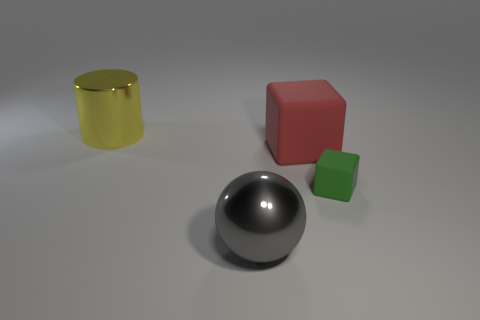Add 2 cylinders. How many objects exist? 6 Subtract 1 cubes. How many cubes are left? 1 Subtract all cyan cylinders. Subtract all brown cubes. How many cylinders are left? 1 Subtract all yellow balls. How many red blocks are left? 1 Subtract all large yellow cylinders. Subtract all small green cylinders. How many objects are left? 3 Add 4 small green objects. How many small green objects are left? 5 Add 1 big cylinders. How many big cylinders exist? 2 Subtract 1 yellow cylinders. How many objects are left? 3 Subtract all cylinders. How many objects are left? 3 